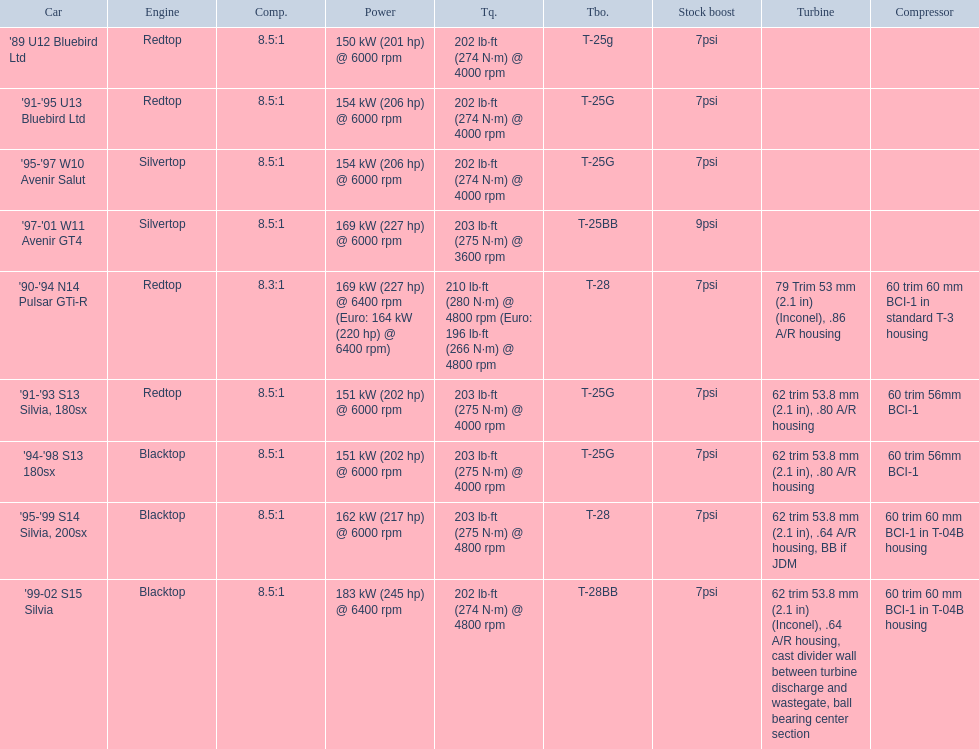How many models utilized the redtop engine? 4. 